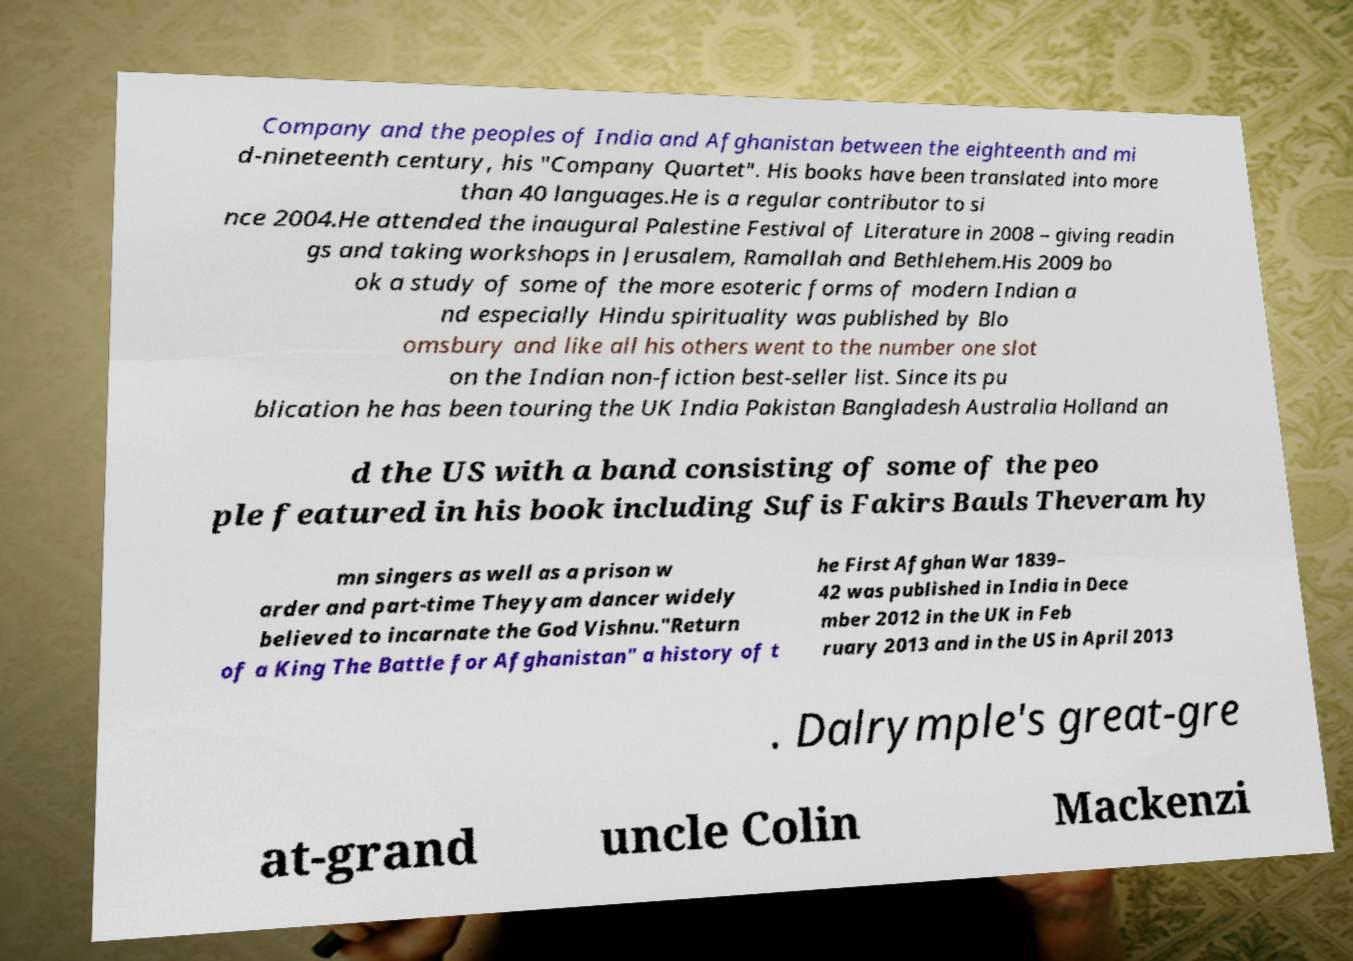Could you extract and type out the text from this image? Company and the peoples of India and Afghanistan between the eighteenth and mi d-nineteenth century, his "Company Quartet". His books have been translated into more than 40 languages.He is a regular contributor to si nce 2004.He attended the inaugural Palestine Festival of Literature in 2008 – giving readin gs and taking workshops in Jerusalem, Ramallah and Bethlehem.His 2009 bo ok a study of some of the more esoteric forms of modern Indian a nd especially Hindu spirituality was published by Blo omsbury and like all his others went to the number one slot on the Indian non-fiction best-seller list. Since its pu blication he has been touring the UK India Pakistan Bangladesh Australia Holland an d the US with a band consisting of some of the peo ple featured in his book including Sufis Fakirs Bauls Theveram hy mn singers as well as a prison w arder and part-time Theyyam dancer widely believed to incarnate the God Vishnu."Return of a King The Battle for Afghanistan" a history of t he First Afghan War 1839– 42 was published in India in Dece mber 2012 in the UK in Feb ruary 2013 and in the US in April 2013 . Dalrymple's great-gre at-grand uncle Colin Mackenzi 